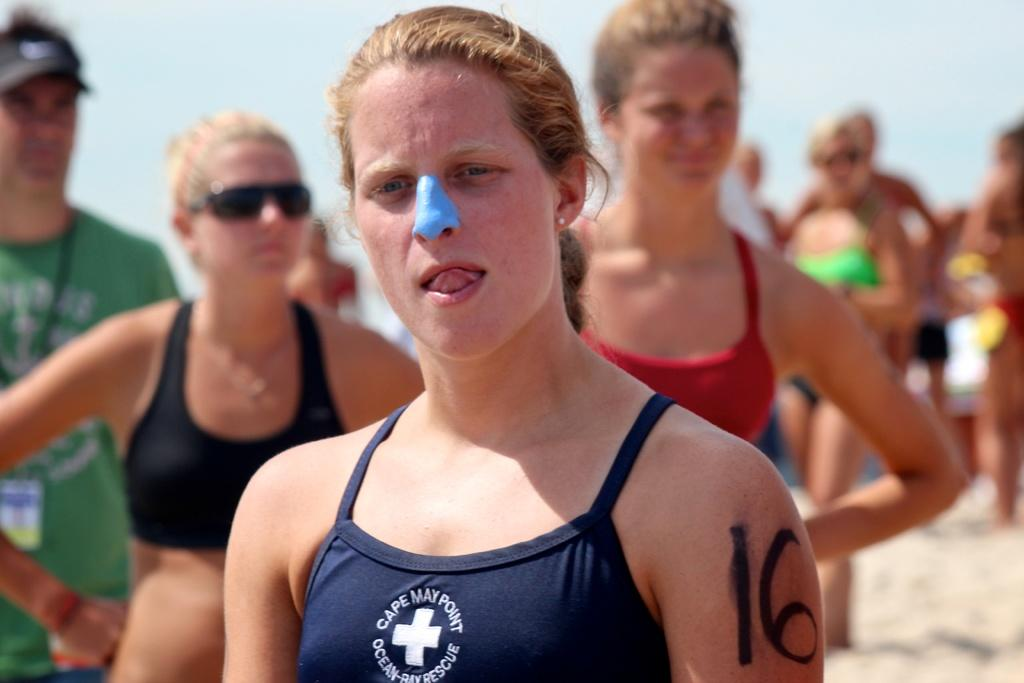<image>
Share a concise interpretation of the image provided. A woman has the number 16 written on her upper arm. 